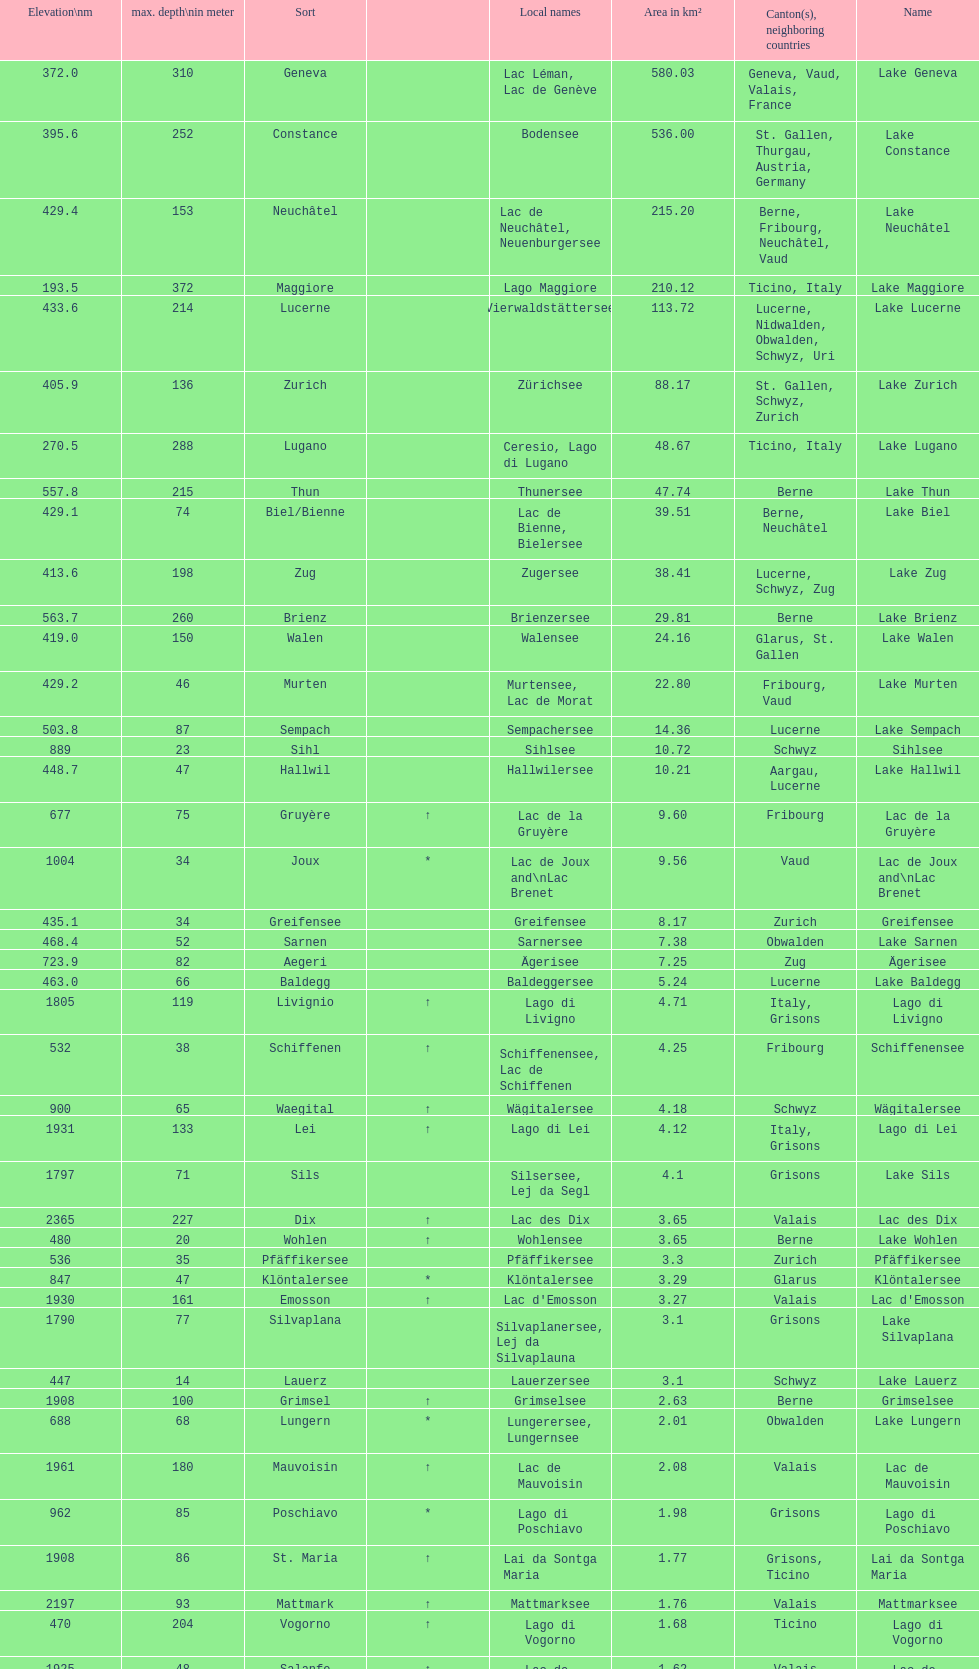What is the combined total depth of the three deepest lakes? 970. 